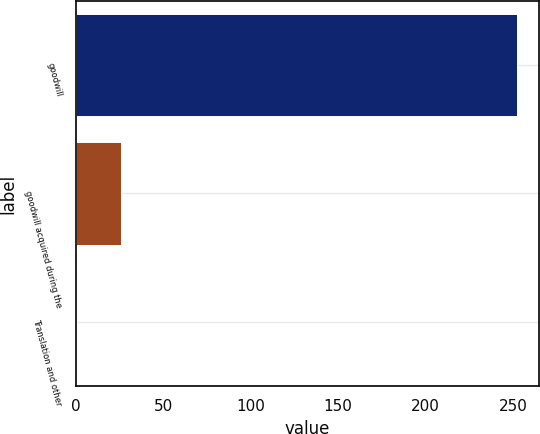Convert chart. <chart><loc_0><loc_0><loc_500><loc_500><bar_chart><fcel>goodwill<fcel>goodwill acquired during the<fcel>Translation and other<nl><fcel>252.4<fcel>25.6<fcel>0.4<nl></chart> 